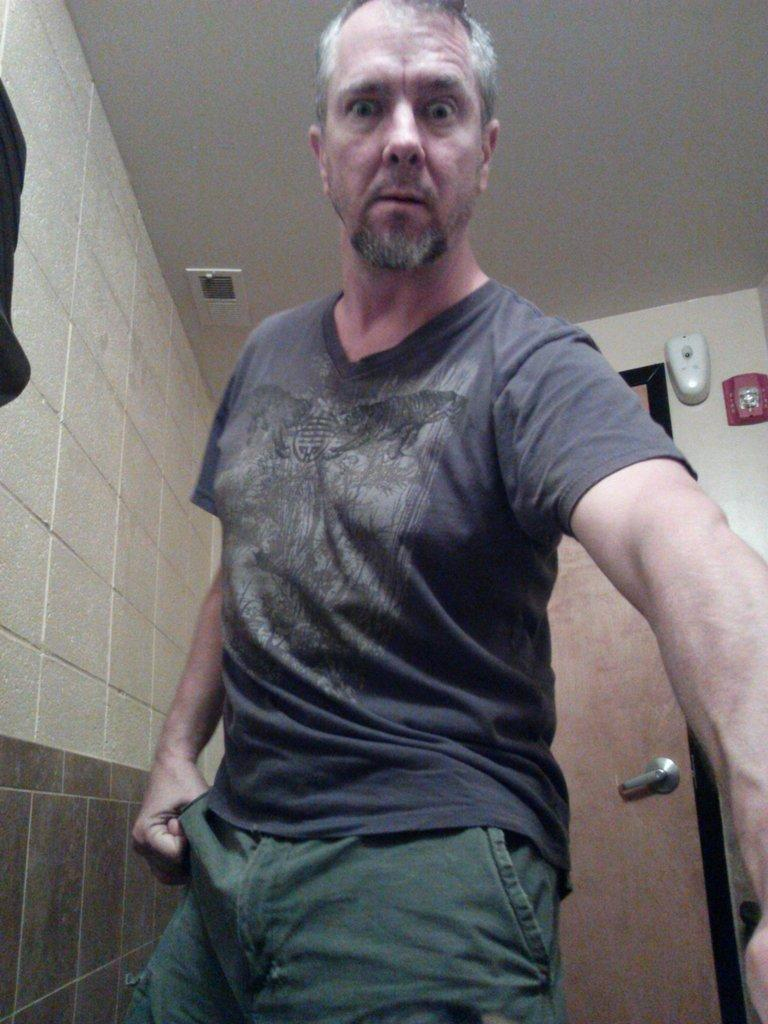Who or what is present in the image? There is a person in the image. What is the person wearing? The person is wearing clothes. Where is the person located in relation to the door? The person is standing in front of a door. What can be seen on the left side of the image? There is a wall on the left side of the image. What type of discussion is taking place between the person and the judge in the image? There is no judge present in the image, and therefore no discussion can be observed. 